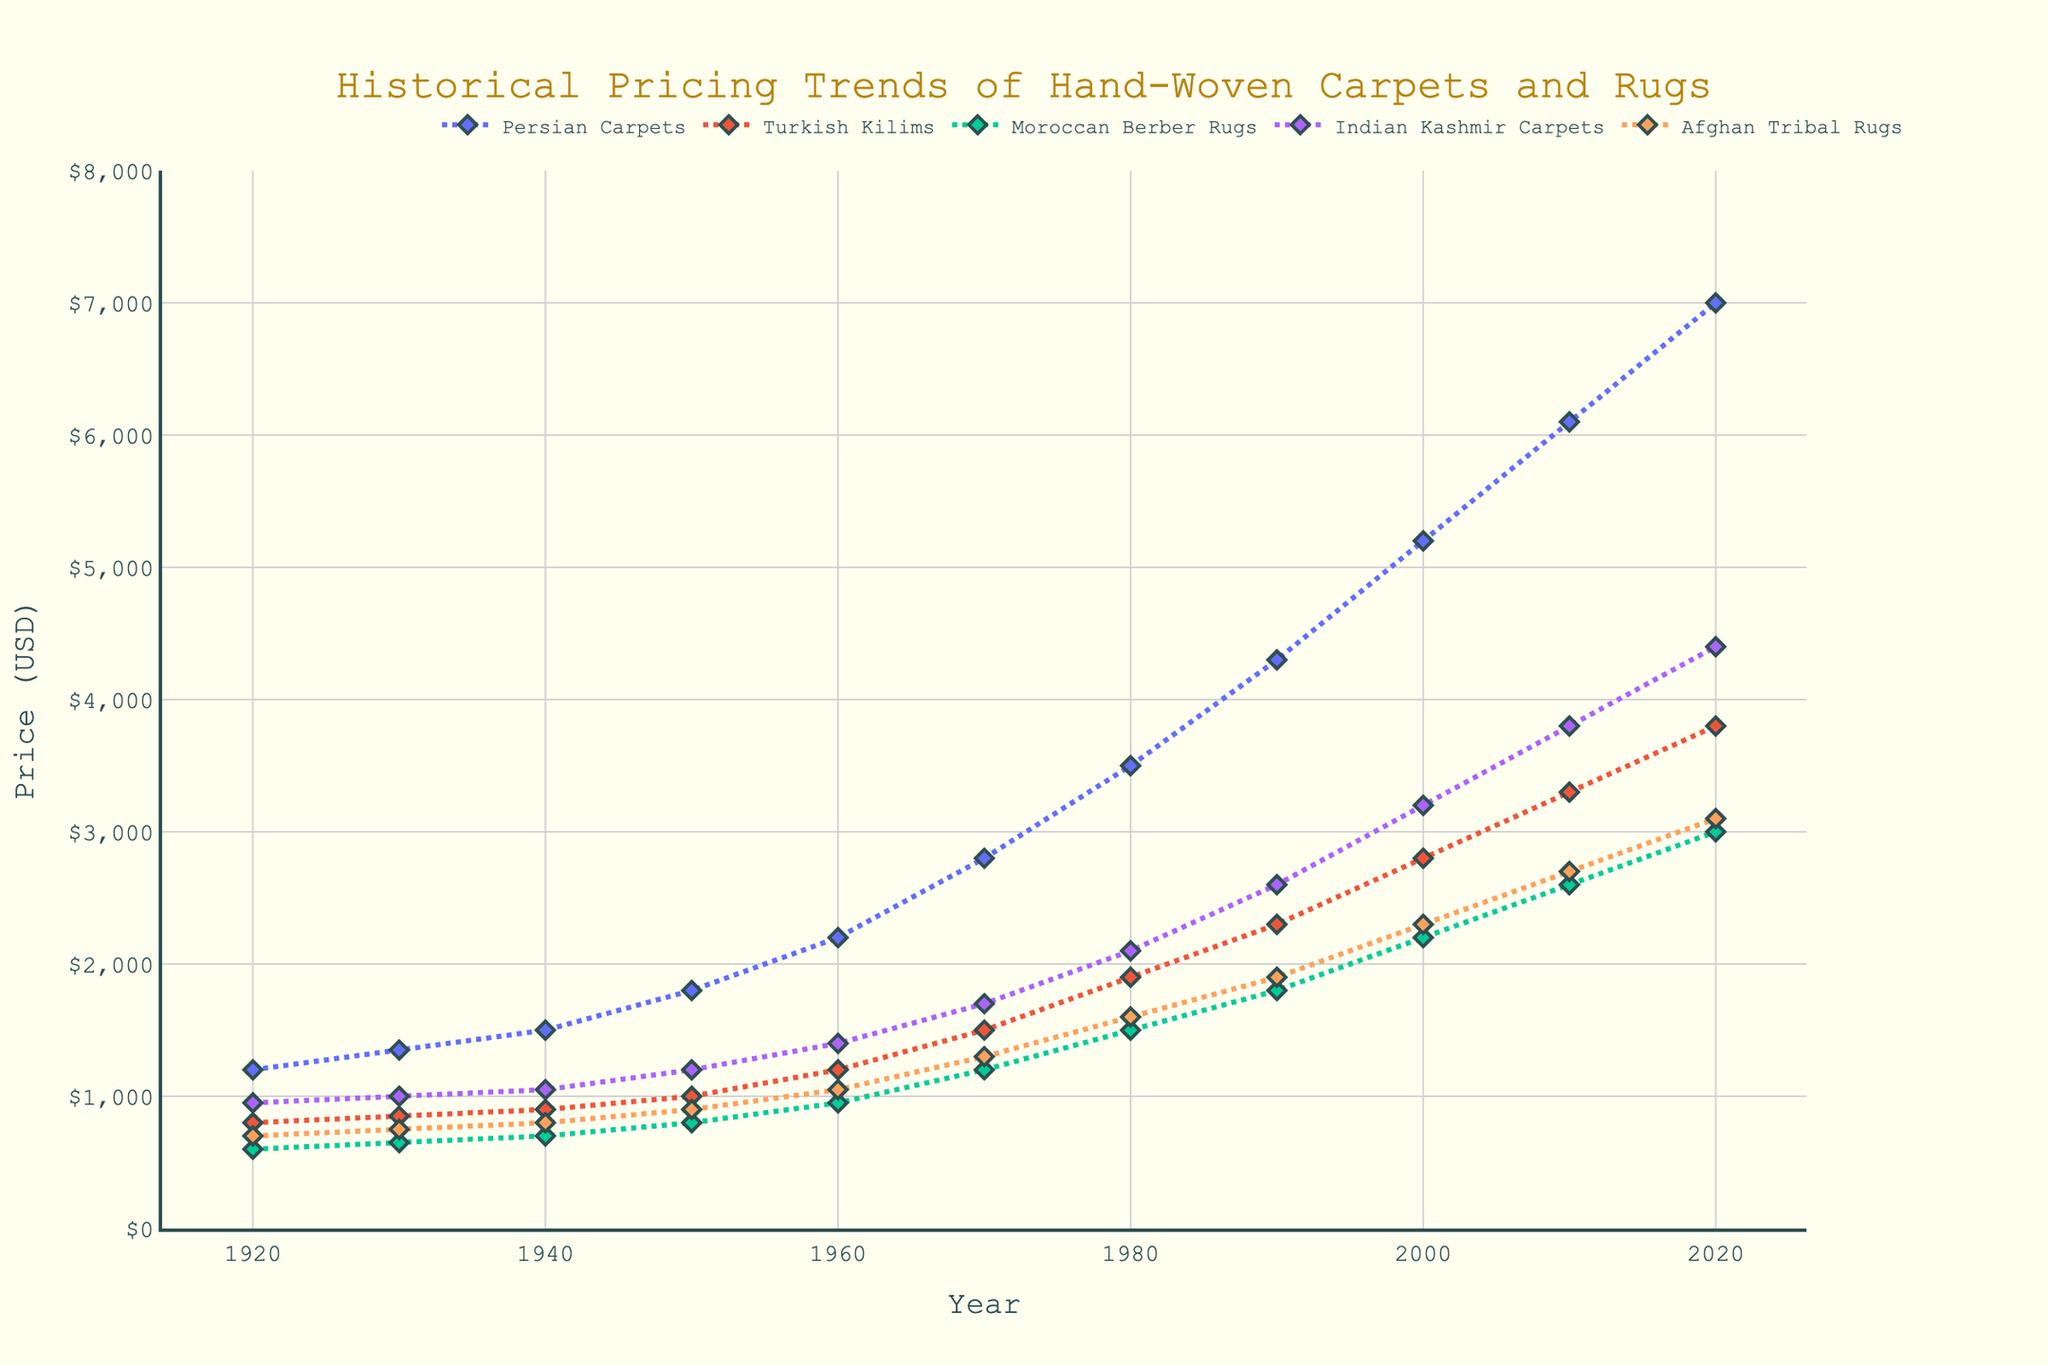What is the trend in the pricing of Persian Carpets over the last century? The line representing Persian Carpets shows a steady increase from 1920 to 2020. It indicates a consistent rise in price over the century.
Answer: Steady increase Which type of carpet had the highest price in 2020? By observing the endpoints of the lines in 2020, Persian Carpets show the highest value among all listed types.
Answer: Persian Carpets How much did the price of Afghan Tribal Rugs increase from 1920 to 2020? The price of Afghan Tribal Rugs in 1920 was 700 dollars, and in 2020 it was 3100 dollars. The increase is 3100 - 700 = 2400 dollars.
Answer: 2400 dollars Which carpet type had the smallest price difference between 1920 and 2020? By examining the start and end points of all lines, Turkish Kilims went from 800 dollars in 1920 to 3800 dollars in 2020, with a difference of 3000 dollars. This is the smallest difference.
Answer: Turkish Kilims What was the average price of Moroccan Berber Rugs in the years 2000, 2010, and 2020? Moroccan Berber Rugs prices were 2200 dollars in 2000, 2600 dollars in 2010, and 3000 dollars in 2020. The average is (2200 + 2600 + 3000) / 3 = 2600 dollars.
Answer: 2600 dollars In which decade did the Indian Kashmir Carpets see the highest growth in price? Looking at the steepness of the line for Indian Kashmir Carpets, the steepest part is between 1950 and 1960, going from 1200 dollars to 1400 dollars indicating the highest growth. The growth is 1400 - 1200 = 200 dollars.
Answer: 1950-1960 Compare the prices of Turkish Kilims and Persian Carpets in 1950. Which was more expensive and by how much? In 1950, Turkish Kilims were 1000 dollars and Persian Carpets were 1800 dollars. Persian Carpets were more expensive by 1800 - 1000 = 800 dollars.
Answer: Persian Carpets, by 800 dollars What is the overall trend in the pricing of Moroccan Berber Rugs from 1920 to 2020? The line for Moroccan Berber Rugs shows a steady upward trend from 600 dollars in 1920 to 3000 dollars in 2020, indicating a consistent price increase.
Answer: Steady increase Did the price of Indian Kashmir Carpets ever decrease over the century? The line for Indian Kashmir Carpets is always increasing without any downward slopes, indicating that the price has never decreased.
Answer: No Which two carpet types showed the closest prices in 1970? Observing the lines for 1970, Turkish Kilims were 1500 dollars and Moroccan Berber Rugs were 1200 dollars. These two have the closest prices in this year.
Answer: Turkish Kilims and Moroccan Berber Rugs 